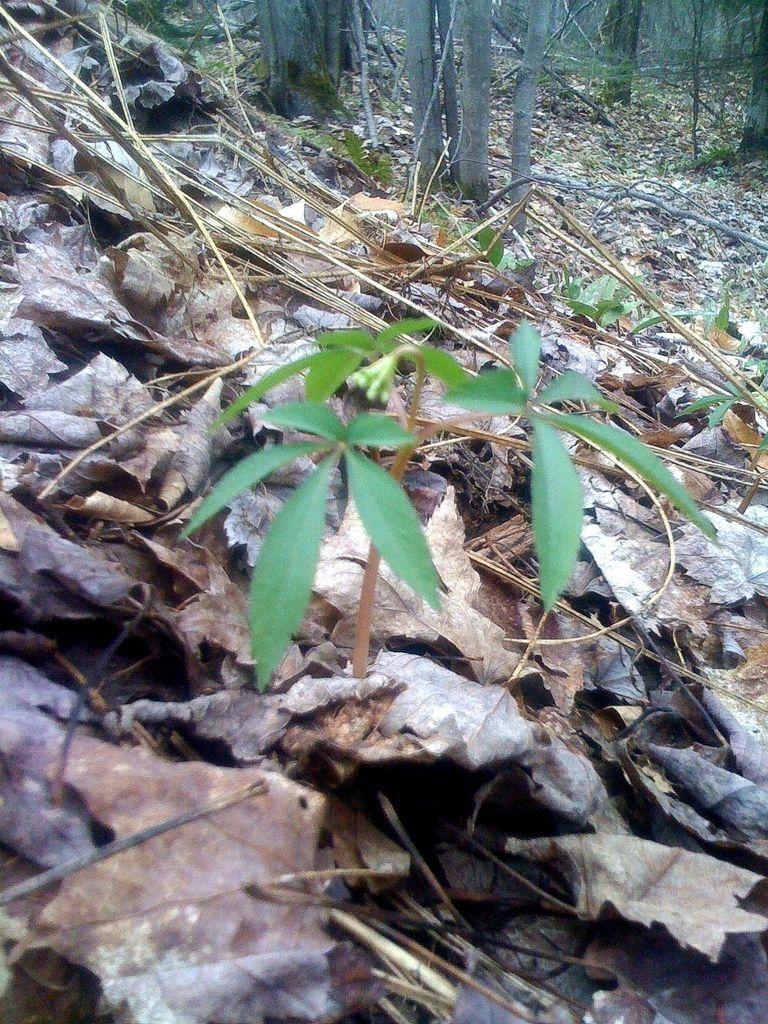Describe this image in one or two sentences. This picture is taken from the forest. In this image, in the middle, we can see a plant with green leaves. In the background, we can see some wooden trunk, trees, at the bottom, we can see the leaves on the land. 